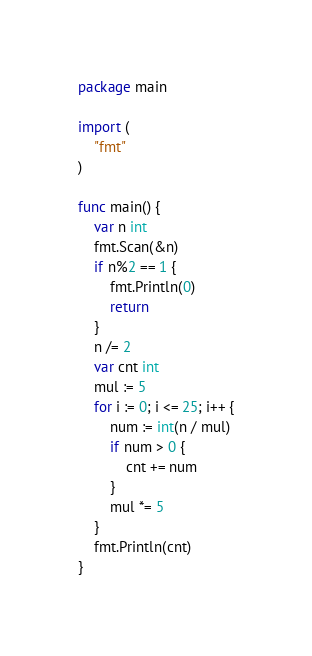Convert code to text. <code><loc_0><loc_0><loc_500><loc_500><_Go_>package main

import (
	"fmt"
)

func main() {
	var n int
	fmt.Scan(&n)
	if n%2 == 1 {
		fmt.Println(0)
		return
	}
	n /= 2
	var cnt int
	mul := 5
	for i := 0; i <= 25; i++ {
		num := int(n / mul)
		if num > 0 {
			cnt += num
		}
		mul *= 5
	}
	fmt.Println(cnt)
}
</code> 